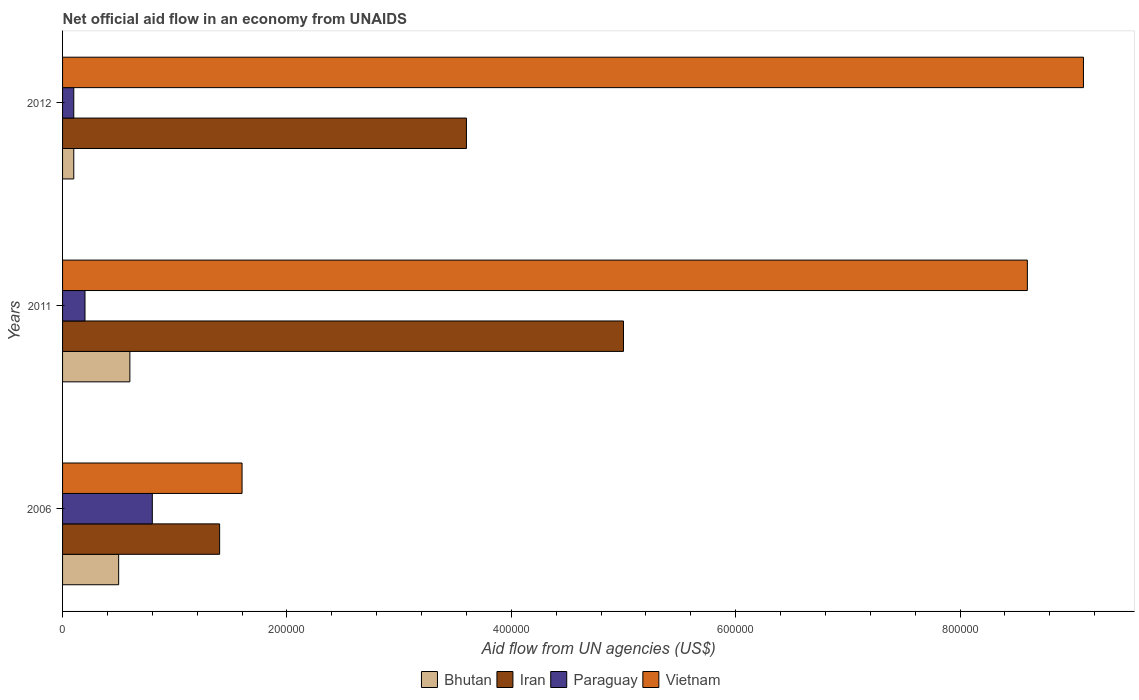How many groups of bars are there?
Your answer should be compact. 3. Are the number of bars per tick equal to the number of legend labels?
Give a very brief answer. Yes. How many bars are there on the 1st tick from the top?
Offer a very short reply. 4. How many bars are there on the 3rd tick from the bottom?
Make the answer very short. 4. What is the label of the 2nd group of bars from the top?
Make the answer very short. 2011. Across all years, what is the maximum net official aid flow in Iran?
Your answer should be very brief. 5.00e+05. Across all years, what is the minimum net official aid flow in Vietnam?
Provide a succinct answer. 1.60e+05. What is the total net official aid flow in Bhutan in the graph?
Offer a terse response. 1.20e+05. What is the difference between the net official aid flow in Vietnam in 2011 and that in 2012?
Your response must be concise. -5.00e+04. What is the difference between the net official aid flow in Paraguay in 2006 and the net official aid flow in Iran in 2011?
Offer a very short reply. -4.20e+05. What is the average net official aid flow in Vietnam per year?
Your response must be concise. 6.43e+05. In the year 2011, what is the difference between the net official aid flow in Vietnam and net official aid flow in Paraguay?
Provide a succinct answer. 8.40e+05. In how many years, is the net official aid flow in Iran greater than 560000 US$?
Provide a succinct answer. 0. What is the ratio of the net official aid flow in Vietnam in 2006 to that in 2012?
Make the answer very short. 0.18. Is the difference between the net official aid flow in Vietnam in 2011 and 2012 greater than the difference between the net official aid flow in Paraguay in 2011 and 2012?
Provide a short and direct response. No. What is the difference between the highest and the second highest net official aid flow in Iran?
Provide a succinct answer. 1.40e+05. What does the 1st bar from the top in 2006 represents?
Provide a succinct answer. Vietnam. What does the 3rd bar from the bottom in 2012 represents?
Offer a very short reply. Paraguay. Is it the case that in every year, the sum of the net official aid flow in Vietnam and net official aid flow in Iran is greater than the net official aid flow in Paraguay?
Your answer should be very brief. Yes. How many bars are there?
Give a very brief answer. 12. Where does the legend appear in the graph?
Your answer should be very brief. Bottom center. How are the legend labels stacked?
Your answer should be very brief. Horizontal. What is the title of the graph?
Provide a short and direct response. Net official aid flow in an economy from UNAIDS. What is the label or title of the X-axis?
Your answer should be very brief. Aid flow from UN agencies (US$). What is the label or title of the Y-axis?
Keep it short and to the point. Years. What is the Aid flow from UN agencies (US$) in Bhutan in 2006?
Keep it short and to the point. 5.00e+04. What is the Aid flow from UN agencies (US$) in Iran in 2006?
Give a very brief answer. 1.40e+05. What is the Aid flow from UN agencies (US$) of Paraguay in 2006?
Give a very brief answer. 8.00e+04. What is the Aid flow from UN agencies (US$) in Vietnam in 2006?
Ensure brevity in your answer.  1.60e+05. What is the Aid flow from UN agencies (US$) in Bhutan in 2011?
Give a very brief answer. 6.00e+04. What is the Aid flow from UN agencies (US$) in Vietnam in 2011?
Ensure brevity in your answer.  8.60e+05. What is the Aid flow from UN agencies (US$) of Bhutan in 2012?
Offer a terse response. 10000. What is the Aid flow from UN agencies (US$) of Iran in 2012?
Offer a very short reply. 3.60e+05. What is the Aid flow from UN agencies (US$) of Vietnam in 2012?
Your answer should be compact. 9.10e+05. Across all years, what is the maximum Aid flow from UN agencies (US$) in Bhutan?
Offer a very short reply. 6.00e+04. Across all years, what is the maximum Aid flow from UN agencies (US$) of Iran?
Your answer should be compact. 5.00e+05. Across all years, what is the maximum Aid flow from UN agencies (US$) of Vietnam?
Provide a succinct answer. 9.10e+05. Across all years, what is the minimum Aid flow from UN agencies (US$) of Paraguay?
Provide a succinct answer. 10000. What is the total Aid flow from UN agencies (US$) of Iran in the graph?
Offer a terse response. 1.00e+06. What is the total Aid flow from UN agencies (US$) of Vietnam in the graph?
Offer a very short reply. 1.93e+06. What is the difference between the Aid flow from UN agencies (US$) of Bhutan in 2006 and that in 2011?
Offer a very short reply. -10000. What is the difference between the Aid flow from UN agencies (US$) in Iran in 2006 and that in 2011?
Keep it short and to the point. -3.60e+05. What is the difference between the Aid flow from UN agencies (US$) of Paraguay in 2006 and that in 2011?
Your response must be concise. 6.00e+04. What is the difference between the Aid flow from UN agencies (US$) of Vietnam in 2006 and that in 2011?
Keep it short and to the point. -7.00e+05. What is the difference between the Aid flow from UN agencies (US$) of Iran in 2006 and that in 2012?
Keep it short and to the point. -2.20e+05. What is the difference between the Aid flow from UN agencies (US$) of Vietnam in 2006 and that in 2012?
Provide a short and direct response. -7.50e+05. What is the difference between the Aid flow from UN agencies (US$) in Paraguay in 2011 and that in 2012?
Your answer should be compact. 10000. What is the difference between the Aid flow from UN agencies (US$) of Vietnam in 2011 and that in 2012?
Your answer should be very brief. -5.00e+04. What is the difference between the Aid flow from UN agencies (US$) in Bhutan in 2006 and the Aid flow from UN agencies (US$) in Iran in 2011?
Ensure brevity in your answer.  -4.50e+05. What is the difference between the Aid flow from UN agencies (US$) in Bhutan in 2006 and the Aid flow from UN agencies (US$) in Vietnam in 2011?
Give a very brief answer. -8.10e+05. What is the difference between the Aid flow from UN agencies (US$) of Iran in 2006 and the Aid flow from UN agencies (US$) of Paraguay in 2011?
Your response must be concise. 1.20e+05. What is the difference between the Aid flow from UN agencies (US$) of Iran in 2006 and the Aid flow from UN agencies (US$) of Vietnam in 2011?
Make the answer very short. -7.20e+05. What is the difference between the Aid flow from UN agencies (US$) in Paraguay in 2006 and the Aid flow from UN agencies (US$) in Vietnam in 2011?
Your response must be concise. -7.80e+05. What is the difference between the Aid flow from UN agencies (US$) in Bhutan in 2006 and the Aid flow from UN agencies (US$) in Iran in 2012?
Keep it short and to the point. -3.10e+05. What is the difference between the Aid flow from UN agencies (US$) of Bhutan in 2006 and the Aid flow from UN agencies (US$) of Paraguay in 2012?
Keep it short and to the point. 4.00e+04. What is the difference between the Aid flow from UN agencies (US$) of Bhutan in 2006 and the Aid flow from UN agencies (US$) of Vietnam in 2012?
Provide a succinct answer. -8.60e+05. What is the difference between the Aid flow from UN agencies (US$) of Iran in 2006 and the Aid flow from UN agencies (US$) of Paraguay in 2012?
Give a very brief answer. 1.30e+05. What is the difference between the Aid flow from UN agencies (US$) in Iran in 2006 and the Aid flow from UN agencies (US$) in Vietnam in 2012?
Give a very brief answer. -7.70e+05. What is the difference between the Aid flow from UN agencies (US$) in Paraguay in 2006 and the Aid flow from UN agencies (US$) in Vietnam in 2012?
Offer a terse response. -8.30e+05. What is the difference between the Aid flow from UN agencies (US$) of Bhutan in 2011 and the Aid flow from UN agencies (US$) of Iran in 2012?
Ensure brevity in your answer.  -3.00e+05. What is the difference between the Aid flow from UN agencies (US$) in Bhutan in 2011 and the Aid flow from UN agencies (US$) in Vietnam in 2012?
Give a very brief answer. -8.50e+05. What is the difference between the Aid flow from UN agencies (US$) of Iran in 2011 and the Aid flow from UN agencies (US$) of Paraguay in 2012?
Your answer should be compact. 4.90e+05. What is the difference between the Aid flow from UN agencies (US$) in Iran in 2011 and the Aid flow from UN agencies (US$) in Vietnam in 2012?
Ensure brevity in your answer.  -4.10e+05. What is the difference between the Aid flow from UN agencies (US$) of Paraguay in 2011 and the Aid flow from UN agencies (US$) of Vietnam in 2012?
Offer a very short reply. -8.90e+05. What is the average Aid flow from UN agencies (US$) of Iran per year?
Give a very brief answer. 3.33e+05. What is the average Aid flow from UN agencies (US$) in Paraguay per year?
Offer a terse response. 3.67e+04. What is the average Aid flow from UN agencies (US$) of Vietnam per year?
Ensure brevity in your answer.  6.43e+05. In the year 2006, what is the difference between the Aid flow from UN agencies (US$) in Bhutan and Aid flow from UN agencies (US$) in Paraguay?
Provide a succinct answer. -3.00e+04. In the year 2006, what is the difference between the Aid flow from UN agencies (US$) in Bhutan and Aid flow from UN agencies (US$) in Vietnam?
Offer a terse response. -1.10e+05. In the year 2006, what is the difference between the Aid flow from UN agencies (US$) in Iran and Aid flow from UN agencies (US$) in Paraguay?
Offer a very short reply. 6.00e+04. In the year 2006, what is the difference between the Aid flow from UN agencies (US$) in Iran and Aid flow from UN agencies (US$) in Vietnam?
Your answer should be compact. -2.00e+04. In the year 2011, what is the difference between the Aid flow from UN agencies (US$) of Bhutan and Aid flow from UN agencies (US$) of Iran?
Provide a short and direct response. -4.40e+05. In the year 2011, what is the difference between the Aid flow from UN agencies (US$) in Bhutan and Aid flow from UN agencies (US$) in Vietnam?
Keep it short and to the point. -8.00e+05. In the year 2011, what is the difference between the Aid flow from UN agencies (US$) in Iran and Aid flow from UN agencies (US$) in Vietnam?
Make the answer very short. -3.60e+05. In the year 2011, what is the difference between the Aid flow from UN agencies (US$) of Paraguay and Aid flow from UN agencies (US$) of Vietnam?
Give a very brief answer. -8.40e+05. In the year 2012, what is the difference between the Aid flow from UN agencies (US$) of Bhutan and Aid flow from UN agencies (US$) of Iran?
Your response must be concise. -3.50e+05. In the year 2012, what is the difference between the Aid flow from UN agencies (US$) in Bhutan and Aid flow from UN agencies (US$) in Vietnam?
Offer a terse response. -9.00e+05. In the year 2012, what is the difference between the Aid flow from UN agencies (US$) in Iran and Aid flow from UN agencies (US$) in Vietnam?
Offer a very short reply. -5.50e+05. In the year 2012, what is the difference between the Aid flow from UN agencies (US$) of Paraguay and Aid flow from UN agencies (US$) of Vietnam?
Keep it short and to the point. -9.00e+05. What is the ratio of the Aid flow from UN agencies (US$) in Iran in 2006 to that in 2011?
Offer a very short reply. 0.28. What is the ratio of the Aid flow from UN agencies (US$) of Paraguay in 2006 to that in 2011?
Your response must be concise. 4. What is the ratio of the Aid flow from UN agencies (US$) of Vietnam in 2006 to that in 2011?
Make the answer very short. 0.19. What is the ratio of the Aid flow from UN agencies (US$) in Bhutan in 2006 to that in 2012?
Provide a succinct answer. 5. What is the ratio of the Aid flow from UN agencies (US$) of Iran in 2006 to that in 2012?
Offer a terse response. 0.39. What is the ratio of the Aid flow from UN agencies (US$) of Paraguay in 2006 to that in 2012?
Offer a very short reply. 8. What is the ratio of the Aid flow from UN agencies (US$) of Vietnam in 2006 to that in 2012?
Your response must be concise. 0.18. What is the ratio of the Aid flow from UN agencies (US$) of Iran in 2011 to that in 2012?
Your response must be concise. 1.39. What is the ratio of the Aid flow from UN agencies (US$) in Paraguay in 2011 to that in 2012?
Keep it short and to the point. 2. What is the ratio of the Aid flow from UN agencies (US$) in Vietnam in 2011 to that in 2012?
Your answer should be very brief. 0.95. What is the difference between the highest and the second highest Aid flow from UN agencies (US$) of Iran?
Your answer should be very brief. 1.40e+05. What is the difference between the highest and the second highest Aid flow from UN agencies (US$) of Paraguay?
Give a very brief answer. 6.00e+04. What is the difference between the highest and the second highest Aid flow from UN agencies (US$) of Vietnam?
Ensure brevity in your answer.  5.00e+04. What is the difference between the highest and the lowest Aid flow from UN agencies (US$) of Bhutan?
Your answer should be compact. 5.00e+04. What is the difference between the highest and the lowest Aid flow from UN agencies (US$) in Iran?
Make the answer very short. 3.60e+05. What is the difference between the highest and the lowest Aid flow from UN agencies (US$) of Paraguay?
Give a very brief answer. 7.00e+04. What is the difference between the highest and the lowest Aid flow from UN agencies (US$) of Vietnam?
Offer a terse response. 7.50e+05. 